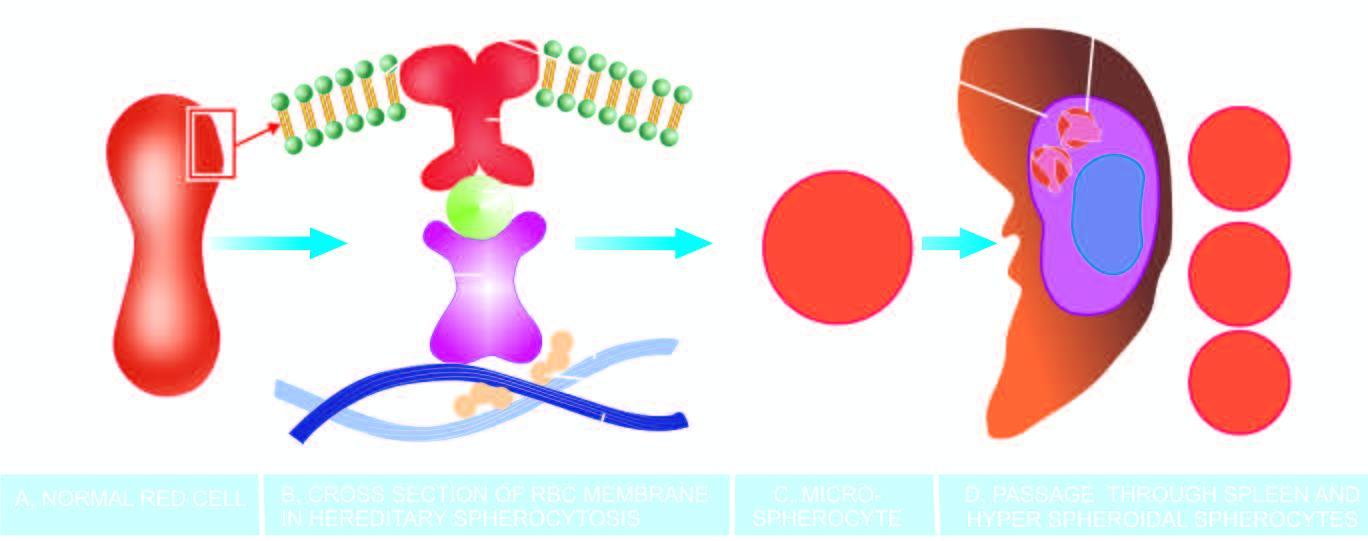do left side lose their cell membrane further during passage through the spleen?
Answer the question using a single word or phrase. No 